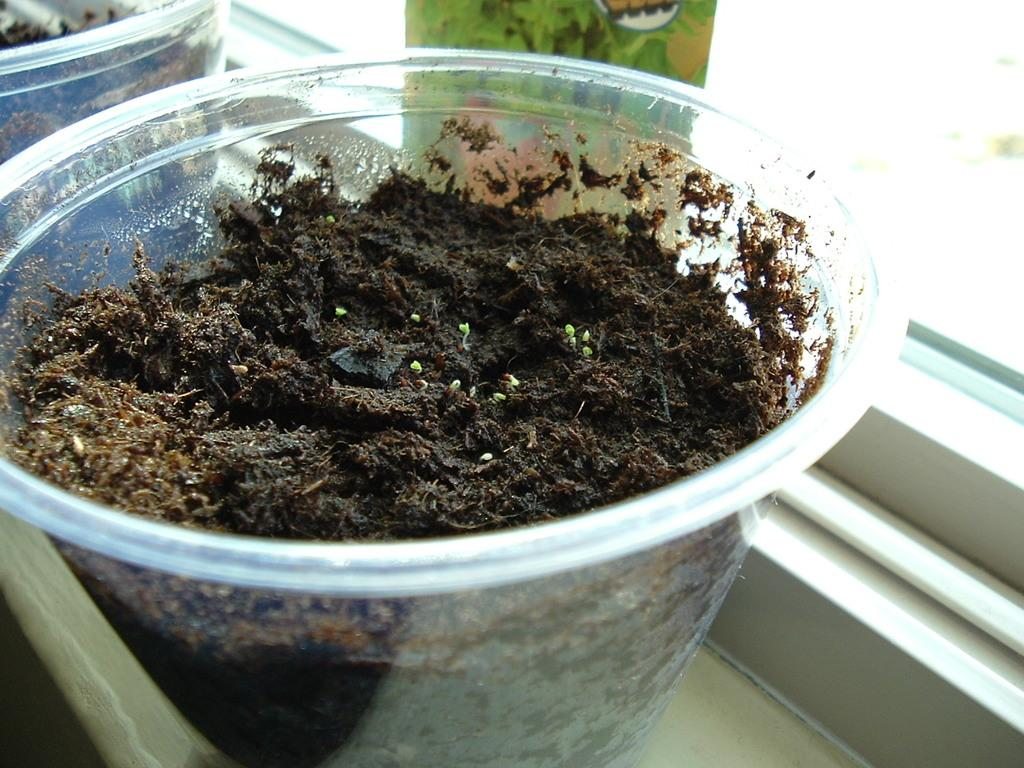What is contained in the jars that are in the center of the image? There is mud in jars in the center of the image. What can be seen in the background of the image? There is a window visible in the background of the image. What type of polish is being applied to the beggar's shoes in the image? There is no beggar or shoes present in the image, and therefore no polish application can be observed. 